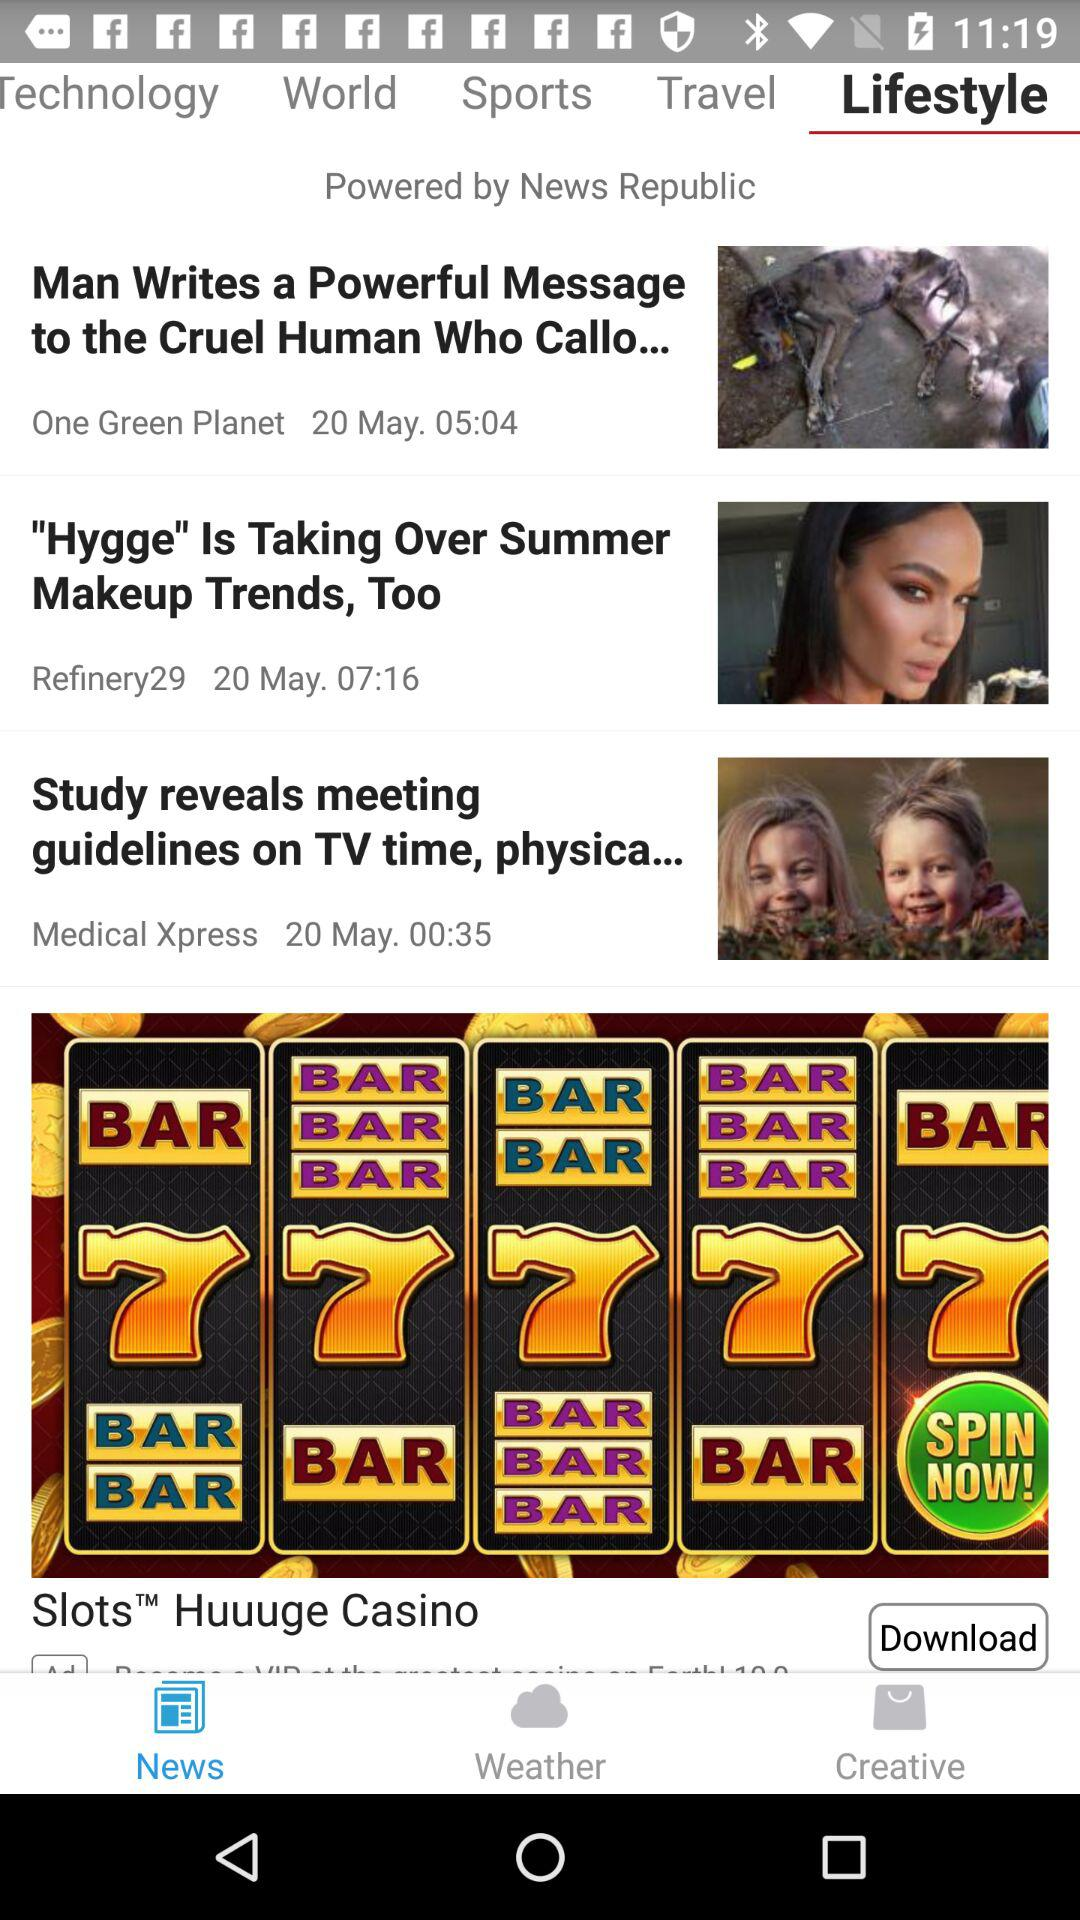How many stories are there in the app?
Answer the question using a single word or phrase. 3 